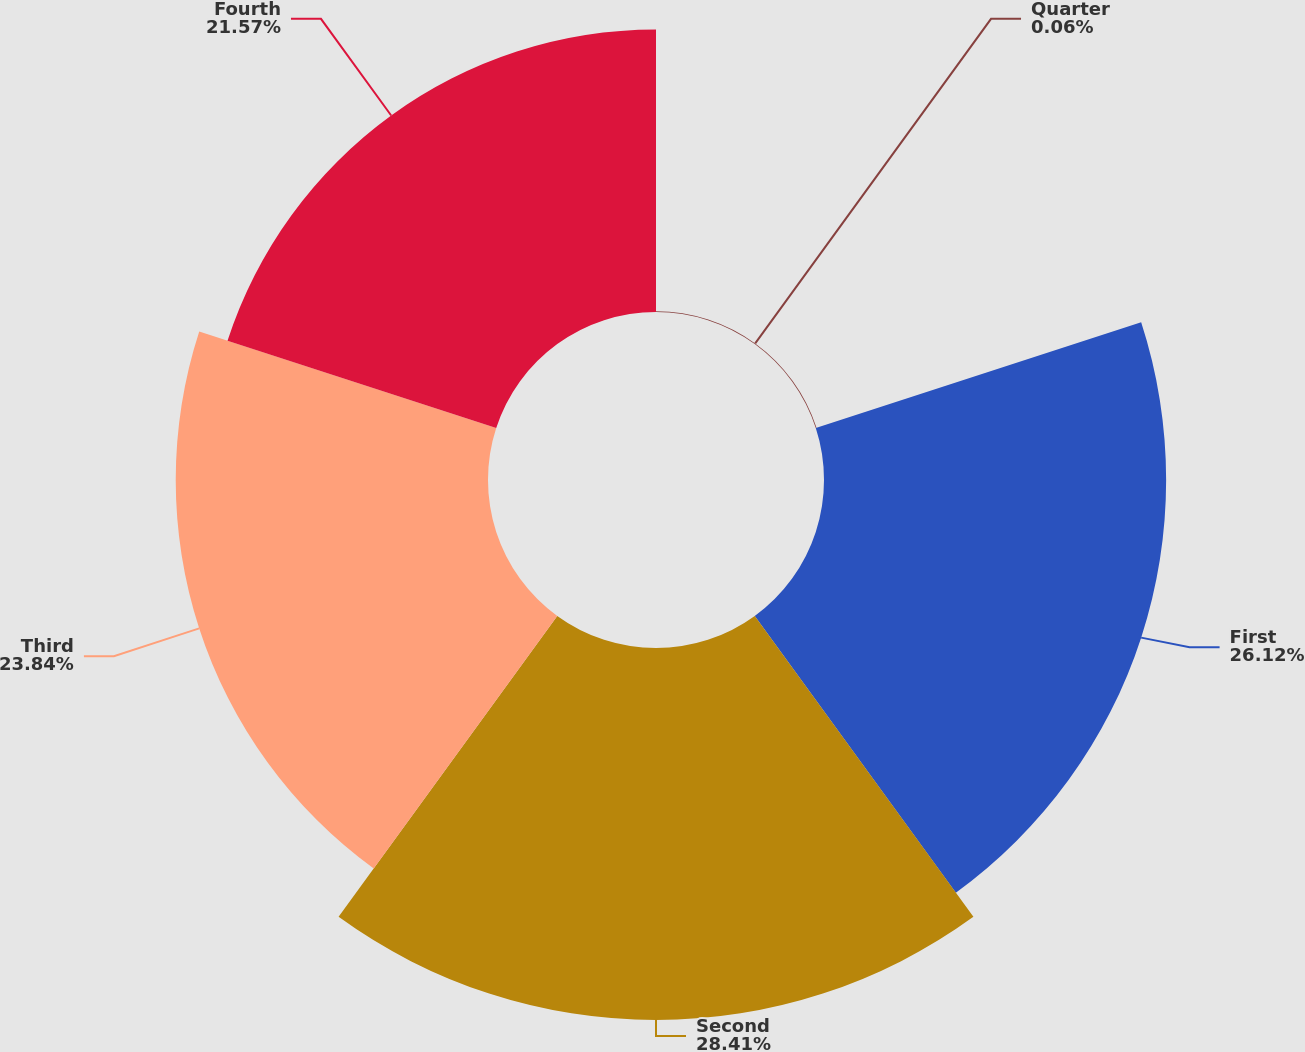Convert chart. <chart><loc_0><loc_0><loc_500><loc_500><pie_chart><fcel>Quarter<fcel>First<fcel>Second<fcel>Third<fcel>Fourth<nl><fcel>0.06%<fcel>26.12%<fcel>28.4%<fcel>23.84%<fcel>21.57%<nl></chart> 